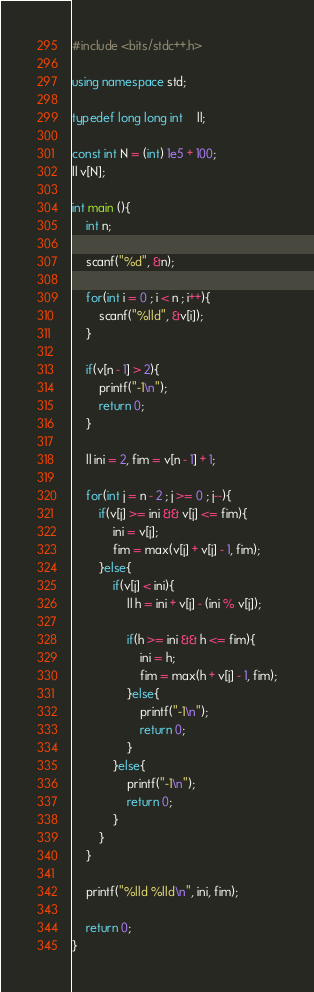<code> <loc_0><loc_0><loc_500><loc_500><_C++_>#include <bits/stdc++.h>

using namespace std;

typedef long long int	ll;

const int N = (int) 1e5 + 100;
ll v[N];

int main (){
	int n;
	
	scanf("%d", &n);

	for(int i = 0 ; i < n ; i++){
		scanf("%lld", &v[i]);
	}
	
	if(v[n - 1] > 2){
		printf("-1\n");
		return 0;
	}
	
	ll ini = 2, fim = v[n - 1] + 1;
	
	for(int j = n - 2 ; j >= 0 ; j--){
		if(v[j] >= ini && v[j] <= fim){
			ini = v[j];
			fim = max(v[j] + v[j] - 1, fim);
		}else{
			if(v[j] < ini){
				ll h = ini + v[j] - (ini % v[j]);
				
				if(h >= ini && h <= fim){
					ini = h;
					fim = max(h + v[j] - 1, fim);
				}else{
					printf("-1\n");
					return 0;
				}
			}else{
				printf("-1\n");
				return 0;
			}
		}
	}
	
	printf("%lld %lld\n", ini, fim);
	
	return 0;
}</code> 